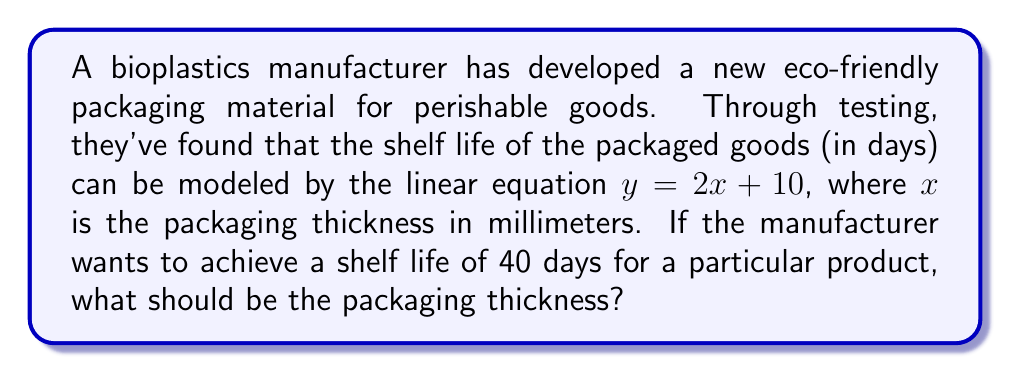Show me your answer to this math problem. To solve this problem, we'll use the given linear equation and follow these steps:

1) The linear equation is given as:
   $y = 2x + 10$

   Where:
   $y$ = shelf life in days
   $x$ = packaging thickness in millimeters

2) We want to find $x$ when $y = 40$ days. Let's substitute this into our equation:

   $40 = 2x + 10$

3) Now, we need to solve for $x$. First, subtract 10 from both sides:

   $40 - 10 = 2x + 10 - 10$
   $30 = 2x$

4) Finally, divide both sides by 2:

   $\frac{30}{2} = \frac{2x}{2}$
   $15 = x$

Therefore, the packaging thickness should be 15 millimeters to achieve a shelf life of 40 days.
Answer: 15 mm 